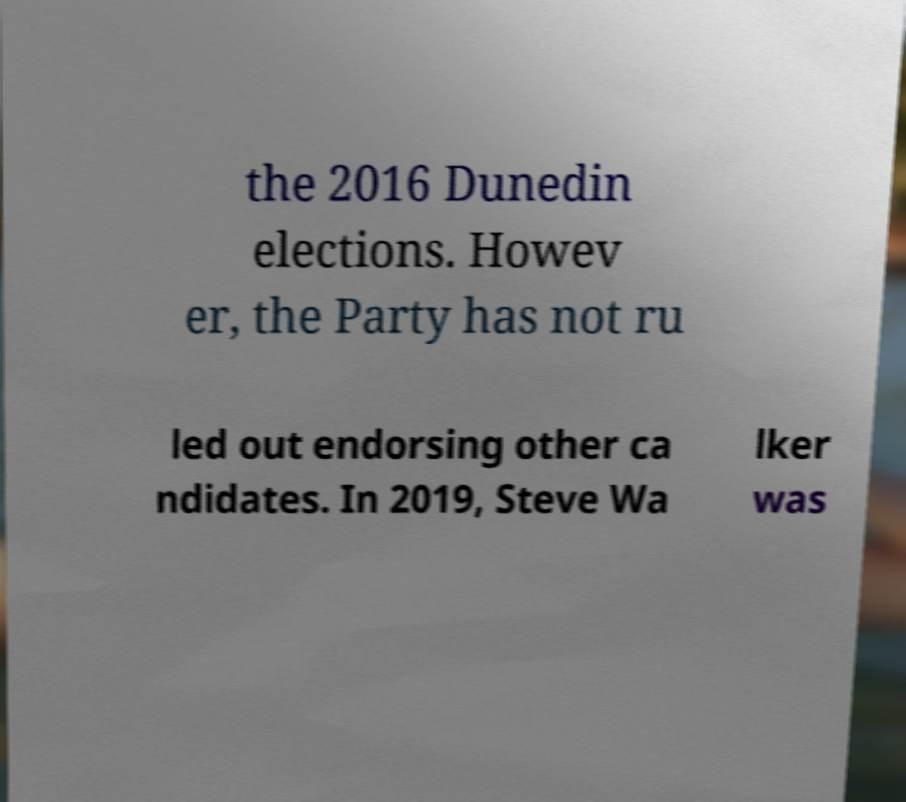For documentation purposes, I need the text within this image transcribed. Could you provide that? the 2016 Dunedin elections. Howev er, the Party has not ru led out endorsing other ca ndidates. In 2019, Steve Wa lker was 